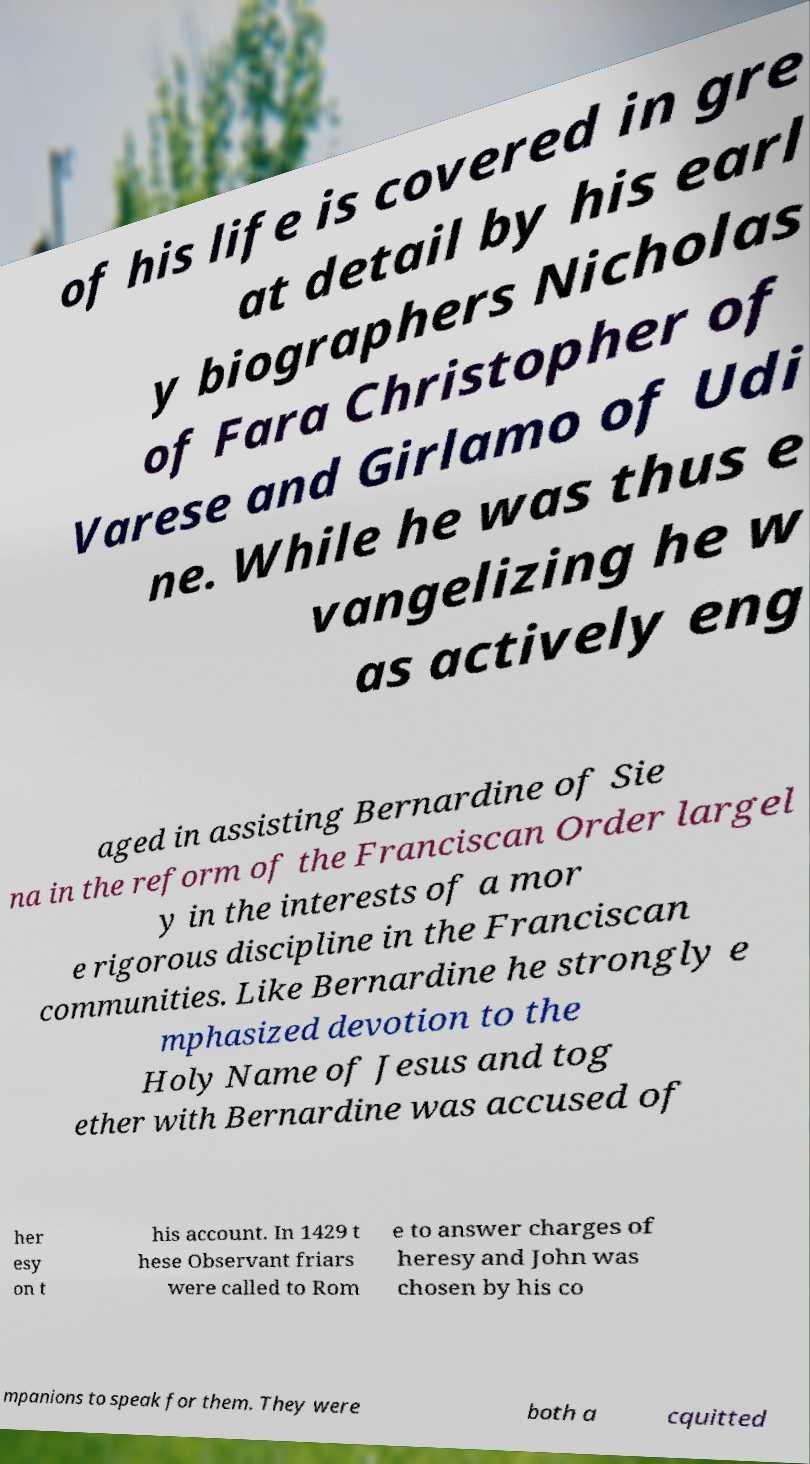Please read and relay the text visible in this image. What does it say? of his life is covered in gre at detail by his earl y biographers Nicholas of Fara Christopher of Varese and Girlamo of Udi ne. While he was thus e vangelizing he w as actively eng aged in assisting Bernardine of Sie na in the reform of the Franciscan Order largel y in the interests of a mor e rigorous discipline in the Franciscan communities. Like Bernardine he strongly e mphasized devotion to the Holy Name of Jesus and tog ether with Bernardine was accused of her esy on t his account. In 1429 t hese Observant friars were called to Rom e to answer charges of heresy and John was chosen by his co mpanions to speak for them. They were both a cquitted 